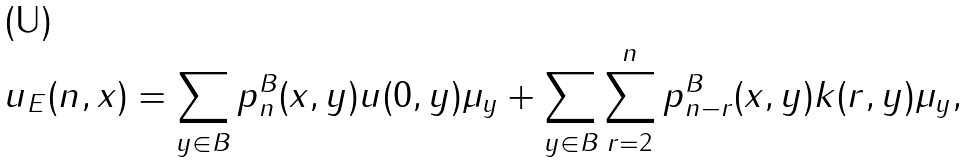<formula> <loc_0><loc_0><loc_500><loc_500>u _ { E } ( n , x ) = \sum _ { y \in B } p ^ { B } _ { n } ( x , y ) u ( 0 , y ) \mu _ { y } + \sum _ { y \in B } \sum _ { r = 2 } ^ { n } p ^ { B } _ { n - r } ( x , y ) k ( r , y ) \mu _ { y } ,</formula> 